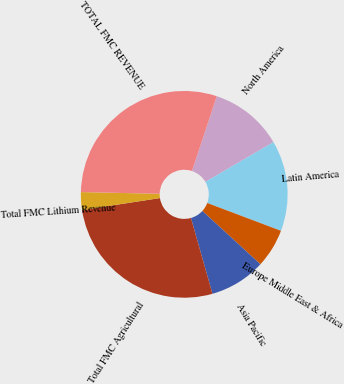<chart> <loc_0><loc_0><loc_500><loc_500><pie_chart><fcel>North America<fcel>Latin America<fcel>Europe Middle East & Africa<fcel>Asia Pacific<fcel>Total FMC Agricultural<fcel>Total FMC Lithium Revenue<fcel>TOTAL FMC REVENUE<nl><fcel>11.47%<fcel>14.17%<fcel>6.08%<fcel>8.78%<fcel>26.97%<fcel>2.78%<fcel>29.75%<nl></chart> 